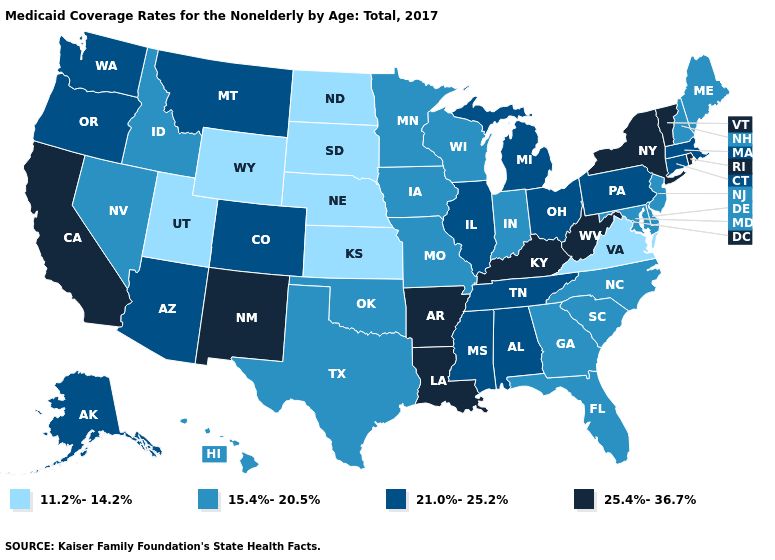What is the value of New York?
Quick response, please. 25.4%-36.7%. Is the legend a continuous bar?
Short answer required. No. Name the states that have a value in the range 15.4%-20.5%?
Quick response, please. Delaware, Florida, Georgia, Hawaii, Idaho, Indiana, Iowa, Maine, Maryland, Minnesota, Missouri, Nevada, New Hampshire, New Jersey, North Carolina, Oklahoma, South Carolina, Texas, Wisconsin. Name the states that have a value in the range 25.4%-36.7%?
Give a very brief answer. Arkansas, California, Kentucky, Louisiana, New Mexico, New York, Rhode Island, Vermont, West Virginia. What is the lowest value in the USA?
Quick response, please. 11.2%-14.2%. Name the states that have a value in the range 11.2%-14.2%?
Short answer required. Kansas, Nebraska, North Dakota, South Dakota, Utah, Virginia, Wyoming. Does the map have missing data?
Write a very short answer. No. Does the map have missing data?
Concise answer only. No. Among the states that border Montana , which have the lowest value?
Quick response, please. North Dakota, South Dakota, Wyoming. Name the states that have a value in the range 21.0%-25.2%?
Be succinct. Alabama, Alaska, Arizona, Colorado, Connecticut, Illinois, Massachusetts, Michigan, Mississippi, Montana, Ohio, Oregon, Pennsylvania, Tennessee, Washington. Name the states that have a value in the range 11.2%-14.2%?
Short answer required. Kansas, Nebraska, North Dakota, South Dakota, Utah, Virginia, Wyoming. What is the value of Arkansas?
Write a very short answer. 25.4%-36.7%. What is the value of New Mexico?
Give a very brief answer. 25.4%-36.7%. 